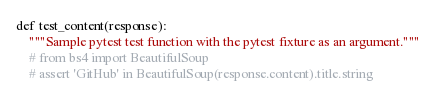Convert code to text. <code><loc_0><loc_0><loc_500><loc_500><_Python_>
def test_content(response):
    """Sample pytest test function with the pytest fixture as an argument."""
    # from bs4 import BeautifulSoup
    # assert 'GitHub' in BeautifulSoup(response.content).title.string
</code> 